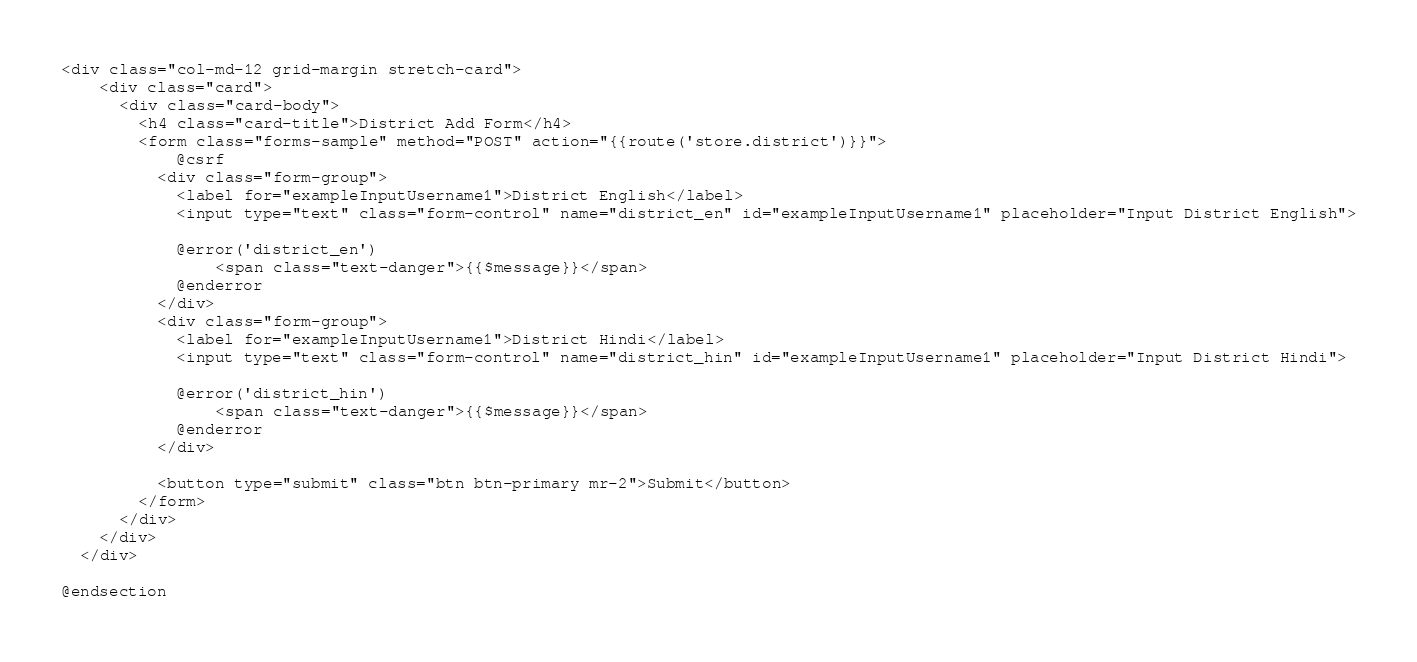Convert code to text. <code><loc_0><loc_0><loc_500><loc_500><_PHP_><div class="col-md-12 grid-margin stretch-card">
    <div class="card">
      <div class="card-body">
        <h4 class="card-title">District Add Form</h4>
        <form class="forms-sample" method="POST" action="{{route('store.district')}}">
            @csrf
          <div class="form-group">
            <label for="exampleInputUsername1">District English</label>
            <input type="text" class="form-control" name="district_en" id="exampleInputUsername1" placeholder="Input District English">

            @error('district_en')
                <span class="text-danger">{{$message}}</span>
            @enderror
          </div>
          <div class="form-group">
            <label for="exampleInputUsername1">District Hindi</label>
            <input type="text" class="form-control" name="district_hin" id="exampleInputUsername1" placeholder="Input District Hindi">

            @error('district_hin')
                <span class="text-danger">{{$message}}</span>
            @enderror
          </div>

          <button type="submit" class="btn btn-primary mr-2">Submit</button>
        </form>
      </div>
    </div>
  </div>

@endsection
</code> 